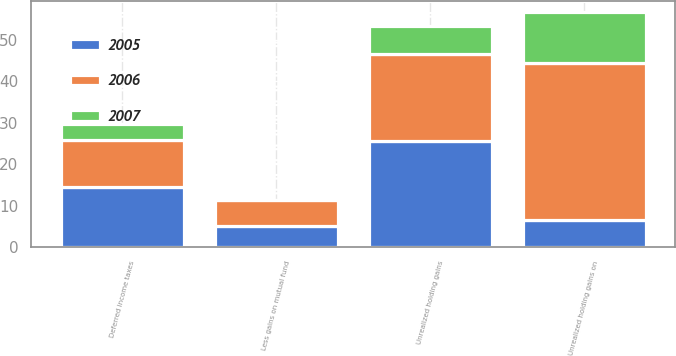<chart> <loc_0><loc_0><loc_500><loc_500><stacked_bar_chart><ecel><fcel>Unrealized holding gains on<fcel>Less gains on mutual fund<fcel>Unrealized holding gains<fcel>Deferred income taxes<nl><fcel>2007<fcel>12.1<fcel>0<fcel>6.8<fcel>3.8<nl><fcel>2006<fcel>38<fcel>6.3<fcel>20.8<fcel>11.4<nl><fcel>2005<fcel>6.55<fcel>5.2<fcel>25.7<fcel>14.5<nl></chart> 